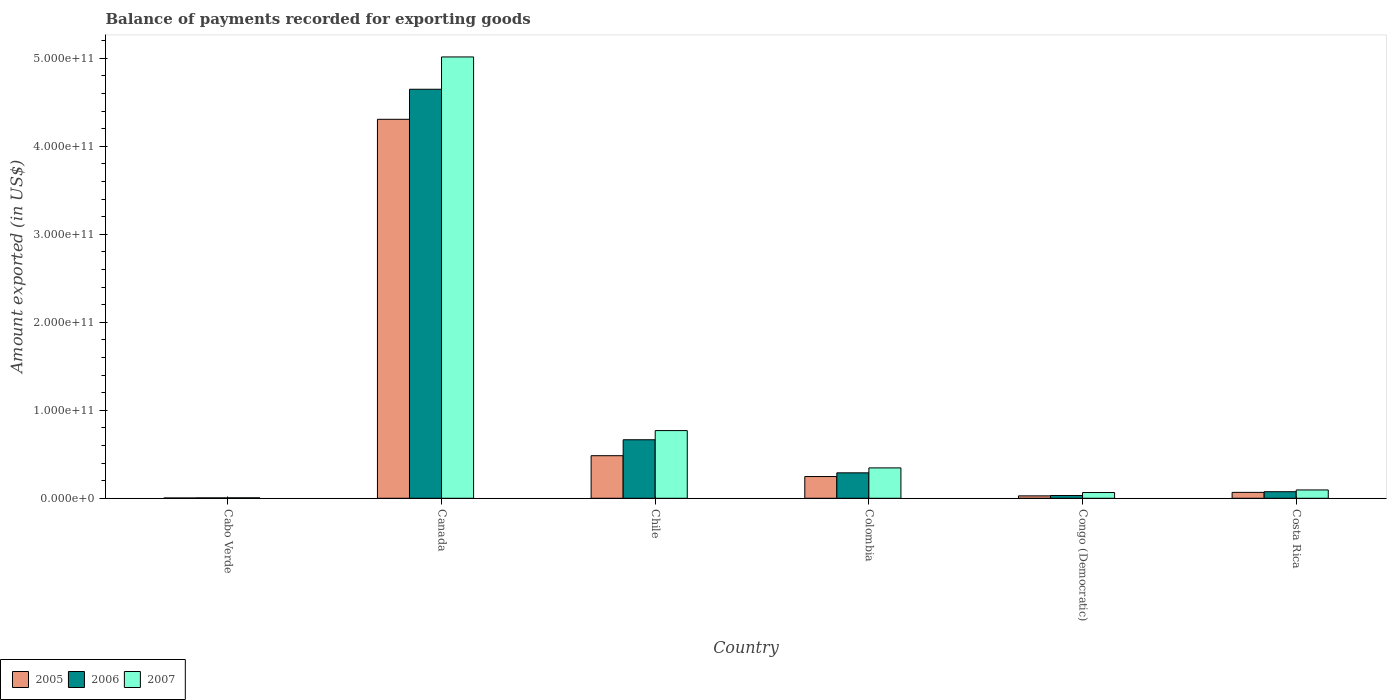How many different coloured bars are there?
Provide a succinct answer. 3. Are the number of bars on each tick of the X-axis equal?
Provide a succinct answer. Yes. How many bars are there on the 2nd tick from the left?
Provide a succinct answer. 3. How many bars are there on the 6th tick from the right?
Provide a succinct answer. 3. What is the label of the 5th group of bars from the left?
Keep it short and to the point. Congo (Democratic). In how many cases, is the number of bars for a given country not equal to the number of legend labels?
Your answer should be compact. 0. What is the amount exported in 2007 in Chile?
Make the answer very short. 7.69e+1. Across all countries, what is the maximum amount exported in 2006?
Make the answer very short. 4.65e+11. Across all countries, what is the minimum amount exported in 2007?
Your answer should be compact. 5.66e+08. In which country was the amount exported in 2007 minimum?
Your answer should be compact. Cabo Verde. What is the total amount exported in 2005 in the graph?
Offer a very short reply. 5.14e+11. What is the difference between the amount exported in 2006 in Chile and that in Colombia?
Ensure brevity in your answer.  3.76e+1. What is the difference between the amount exported in 2005 in Congo (Democratic) and the amount exported in 2006 in Canada?
Offer a terse response. -4.62e+11. What is the average amount exported in 2006 per country?
Ensure brevity in your answer.  9.52e+1. What is the difference between the amount exported of/in 2007 and amount exported of/in 2006 in Canada?
Provide a succinct answer. 3.67e+1. In how many countries, is the amount exported in 2005 greater than 380000000000 US$?
Your answer should be compact. 1. What is the ratio of the amount exported in 2007 in Colombia to that in Congo (Democratic)?
Offer a terse response. 5.28. Is the amount exported in 2006 in Canada less than that in Congo (Democratic)?
Keep it short and to the point. No. What is the difference between the highest and the second highest amount exported in 2006?
Give a very brief answer. 4.36e+11. What is the difference between the highest and the lowest amount exported in 2005?
Keep it short and to the point. 4.30e+11. In how many countries, is the amount exported in 2007 greater than the average amount exported in 2007 taken over all countries?
Offer a very short reply. 1. Is the sum of the amount exported in 2007 in Canada and Costa Rica greater than the maximum amount exported in 2005 across all countries?
Your answer should be very brief. Yes. What does the 3rd bar from the left in Colombia represents?
Your answer should be compact. 2007. Is it the case that in every country, the sum of the amount exported in 2006 and amount exported in 2005 is greater than the amount exported in 2007?
Give a very brief answer. No. Are all the bars in the graph horizontal?
Make the answer very short. No. How many countries are there in the graph?
Provide a short and direct response. 6. What is the difference between two consecutive major ticks on the Y-axis?
Give a very brief answer. 1.00e+11. Are the values on the major ticks of Y-axis written in scientific E-notation?
Your response must be concise. Yes. Does the graph contain any zero values?
Your answer should be very brief. No. Does the graph contain grids?
Your answer should be compact. No. How are the legend labels stacked?
Ensure brevity in your answer.  Horizontal. What is the title of the graph?
Give a very brief answer. Balance of payments recorded for exporting goods. Does "1994" appear as one of the legend labels in the graph?
Offer a terse response. No. What is the label or title of the X-axis?
Offer a terse response. Country. What is the label or title of the Y-axis?
Provide a short and direct response. Amount exported (in US$). What is the Amount exported (in US$) of 2005 in Cabo Verde?
Provide a succinct answer. 3.54e+08. What is the Amount exported (in US$) in 2006 in Cabo Verde?
Provide a succinct answer. 4.72e+08. What is the Amount exported (in US$) in 2007 in Cabo Verde?
Offer a terse response. 5.66e+08. What is the Amount exported (in US$) in 2005 in Canada?
Provide a succinct answer. 4.31e+11. What is the Amount exported (in US$) in 2006 in Canada?
Your answer should be compact. 4.65e+11. What is the Amount exported (in US$) in 2007 in Canada?
Offer a very short reply. 5.02e+11. What is the Amount exported (in US$) of 2005 in Chile?
Offer a terse response. 4.84e+1. What is the Amount exported (in US$) in 2006 in Chile?
Keep it short and to the point. 6.65e+1. What is the Amount exported (in US$) in 2007 in Chile?
Give a very brief answer. 7.69e+1. What is the Amount exported (in US$) of 2005 in Colombia?
Your answer should be compact. 2.47e+1. What is the Amount exported (in US$) in 2006 in Colombia?
Keep it short and to the point. 2.89e+1. What is the Amount exported (in US$) in 2007 in Colombia?
Offer a very short reply. 3.45e+1. What is the Amount exported (in US$) in 2005 in Congo (Democratic)?
Provide a succinct answer. 2.75e+09. What is the Amount exported (in US$) in 2006 in Congo (Democratic)?
Give a very brief answer. 3.14e+09. What is the Amount exported (in US$) in 2007 in Congo (Democratic)?
Make the answer very short. 6.54e+09. What is the Amount exported (in US$) of 2005 in Costa Rica?
Provide a short and direct response. 6.73e+09. What is the Amount exported (in US$) of 2006 in Costa Rica?
Ensure brevity in your answer.  7.47e+09. What is the Amount exported (in US$) in 2007 in Costa Rica?
Provide a succinct answer. 9.48e+09. Across all countries, what is the maximum Amount exported (in US$) in 2005?
Give a very brief answer. 4.31e+11. Across all countries, what is the maximum Amount exported (in US$) in 2006?
Make the answer very short. 4.65e+11. Across all countries, what is the maximum Amount exported (in US$) of 2007?
Give a very brief answer. 5.02e+11. Across all countries, what is the minimum Amount exported (in US$) of 2005?
Offer a terse response. 3.54e+08. Across all countries, what is the minimum Amount exported (in US$) of 2006?
Your answer should be very brief. 4.72e+08. Across all countries, what is the minimum Amount exported (in US$) in 2007?
Offer a very short reply. 5.66e+08. What is the total Amount exported (in US$) in 2005 in the graph?
Offer a very short reply. 5.14e+11. What is the total Amount exported (in US$) in 2006 in the graph?
Make the answer very short. 5.71e+11. What is the total Amount exported (in US$) of 2007 in the graph?
Give a very brief answer. 6.30e+11. What is the difference between the Amount exported (in US$) of 2005 in Cabo Verde and that in Canada?
Offer a terse response. -4.30e+11. What is the difference between the Amount exported (in US$) of 2006 in Cabo Verde and that in Canada?
Provide a succinct answer. -4.64e+11. What is the difference between the Amount exported (in US$) in 2007 in Cabo Verde and that in Canada?
Keep it short and to the point. -5.01e+11. What is the difference between the Amount exported (in US$) of 2005 in Cabo Verde and that in Chile?
Your answer should be compact. -4.80e+1. What is the difference between the Amount exported (in US$) in 2006 in Cabo Verde and that in Chile?
Provide a succinct answer. -6.60e+1. What is the difference between the Amount exported (in US$) of 2007 in Cabo Verde and that in Chile?
Offer a very short reply. -7.64e+1. What is the difference between the Amount exported (in US$) in 2005 in Cabo Verde and that in Colombia?
Your answer should be compact. -2.43e+1. What is the difference between the Amount exported (in US$) in 2006 in Cabo Verde and that in Colombia?
Offer a very short reply. -2.84e+1. What is the difference between the Amount exported (in US$) of 2007 in Cabo Verde and that in Colombia?
Make the answer very short. -3.40e+1. What is the difference between the Amount exported (in US$) of 2005 in Cabo Verde and that in Congo (Democratic)?
Your answer should be compact. -2.39e+09. What is the difference between the Amount exported (in US$) in 2006 in Cabo Verde and that in Congo (Democratic)?
Provide a succinct answer. -2.67e+09. What is the difference between the Amount exported (in US$) of 2007 in Cabo Verde and that in Congo (Democratic)?
Offer a terse response. -5.97e+09. What is the difference between the Amount exported (in US$) in 2005 in Cabo Verde and that in Costa Rica?
Provide a short and direct response. -6.37e+09. What is the difference between the Amount exported (in US$) in 2006 in Cabo Verde and that in Costa Rica?
Provide a succinct answer. -7.00e+09. What is the difference between the Amount exported (in US$) of 2007 in Cabo Verde and that in Costa Rica?
Keep it short and to the point. -8.91e+09. What is the difference between the Amount exported (in US$) of 2005 in Canada and that in Chile?
Provide a succinct answer. 3.82e+11. What is the difference between the Amount exported (in US$) in 2006 in Canada and that in Chile?
Provide a short and direct response. 3.98e+11. What is the difference between the Amount exported (in US$) of 2007 in Canada and that in Chile?
Ensure brevity in your answer.  4.25e+11. What is the difference between the Amount exported (in US$) of 2005 in Canada and that in Colombia?
Offer a terse response. 4.06e+11. What is the difference between the Amount exported (in US$) of 2006 in Canada and that in Colombia?
Offer a terse response. 4.36e+11. What is the difference between the Amount exported (in US$) in 2007 in Canada and that in Colombia?
Keep it short and to the point. 4.67e+11. What is the difference between the Amount exported (in US$) of 2005 in Canada and that in Congo (Democratic)?
Your response must be concise. 4.28e+11. What is the difference between the Amount exported (in US$) of 2006 in Canada and that in Congo (Democratic)?
Keep it short and to the point. 4.62e+11. What is the difference between the Amount exported (in US$) in 2007 in Canada and that in Congo (Democratic)?
Offer a terse response. 4.95e+11. What is the difference between the Amount exported (in US$) of 2005 in Canada and that in Costa Rica?
Offer a terse response. 4.24e+11. What is the difference between the Amount exported (in US$) in 2006 in Canada and that in Costa Rica?
Your response must be concise. 4.57e+11. What is the difference between the Amount exported (in US$) of 2007 in Canada and that in Costa Rica?
Provide a succinct answer. 4.92e+11. What is the difference between the Amount exported (in US$) of 2005 in Chile and that in Colombia?
Provide a short and direct response. 2.37e+1. What is the difference between the Amount exported (in US$) in 2006 in Chile and that in Colombia?
Keep it short and to the point. 3.76e+1. What is the difference between the Amount exported (in US$) of 2007 in Chile and that in Colombia?
Provide a short and direct response. 4.24e+1. What is the difference between the Amount exported (in US$) of 2005 in Chile and that in Congo (Democratic)?
Offer a very short reply. 4.57e+1. What is the difference between the Amount exported (in US$) in 2006 in Chile and that in Congo (Democratic)?
Your response must be concise. 6.34e+1. What is the difference between the Amount exported (in US$) in 2007 in Chile and that in Congo (Democratic)?
Give a very brief answer. 7.04e+1. What is the difference between the Amount exported (in US$) of 2005 in Chile and that in Costa Rica?
Provide a short and direct response. 4.17e+1. What is the difference between the Amount exported (in US$) of 2006 in Chile and that in Costa Rica?
Provide a short and direct response. 5.90e+1. What is the difference between the Amount exported (in US$) of 2007 in Chile and that in Costa Rica?
Keep it short and to the point. 6.75e+1. What is the difference between the Amount exported (in US$) of 2005 in Colombia and that in Congo (Democratic)?
Provide a succinct answer. 2.20e+1. What is the difference between the Amount exported (in US$) in 2006 in Colombia and that in Congo (Democratic)?
Make the answer very short. 2.58e+1. What is the difference between the Amount exported (in US$) in 2007 in Colombia and that in Congo (Democratic)?
Your answer should be very brief. 2.80e+1. What is the difference between the Amount exported (in US$) in 2005 in Colombia and that in Costa Rica?
Your response must be concise. 1.80e+1. What is the difference between the Amount exported (in US$) in 2006 in Colombia and that in Costa Rica?
Your answer should be very brief. 2.14e+1. What is the difference between the Amount exported (in US$) in 2007 in Colombia and that in Costa Rica?
Keep it short and to the point. 2.51e+1. What is the difference between the Amount exported (in US$) of 2005 in Congo (Democratic) and that in Costa Rica?
Provide a short and direct response. -3.98e+09. What is the difference between the Amount exported (in US$) in 2006 in Congo (Democratic) and that in Costa Rica?
Give a very brief answer. -4.33e+09. What is the difference between the Amount exported (in US$) of 2007 in Congo (Democratic) and that in Costa Rica?
Your answer should be compact. -2.94e+09. What is the difference between the Amount exported (in US$) in 2005 in Cabo Verde and the Amount exported (in US$) in 2006 in Canada?
Make the answer very short. -4.65e+11. What is the difference between the Amount exported (in US$) of 2005 in Cabo Verde and the Amount exported (in US$) of 2007 in Canada?
Your response must be concise. -5.01e+11. What is the difference between the Amount exported (in US$) of 2006 in Cabo Verde and the Amount exported (in US$) of 2007 in Canada?
Offer a very short reply. -5.01e+11. What is the difference between the Amount exported (in US$) of 2005 in Cabo Verde and the Amount exported (in US$) of 2006 in Chile?
Provide a short and direct response. -6.62e+1. What is the difference between the Amount exported (in US$) in 2005 in Cabo Verde and the Amount exported (in US$) in 2007 in Chile?
Make the answer very short. -7.66e+1. What is the difference between the Amount exported (in US$) in 2006 in Cabo Verde and the Amount exported (in US$) in 2007 in Chile?
Offer a very short reply. -7.65e+1. What is the difference between the Amount exported (in US$) of 2005 in Cabo Verde and the Amount exported (in US$) of 2006 in Colombia?
Make the answer very short. -2.86e+1. What is the difference between the Amount exported (in US$) in 2005 in Cabo Verde and the Amount exported (in US$) in 2007 in Colombia?
Provide a succinct answer. -3.42e+1. What is the difference between the Amount exported (in US$) in 2006 in Cabo Verde and the Amount exported (in US$) in 2007 in Colombia?
Ensure brevity in your answer.  -3.41e+1. What is the difference between the Amount exported (in US$) of 2005 in Cabo Verde and the Amount exported (in US$) of 2006 in Congo (Democratic)?
Ensure brevity in your answer.  -2.78e+09. What is the difference between the Amount exported (in US$) in 2005 in Cabo Verde and the Amount exported (in US$) in 2007 in Congo (Democratic)?
Make the answer very short. -6.19e+09. What is the difference between the Amount exported (in US$) in 2006 in Cabo Verde and the Amount exported (in US$) in 2007 in Congo (Democratic)?
Ensure brevity in your answer.  -6.07e+09. What is the difference between the Amount exported (in US$) in 2005 in Cabo Verde and the Amount exported (in US$) in 2006 in Costa Rica?
Ensure brevity in your answer.  -7.12e+09. What is the difference between the Amount exported (in US$) of 2005 in Cabo Verde and the Amount exported (in US$) of 2007 in Costa Rica?
Offer a very short reply. -9.12e+09. What is the difference between the Amount exported (in US$) of 2006 in Cabo Verde and the Amount exported (in US$) of 2007 in Costa Rica?
Make the answer very short. -9.00e+09. What is the difference between the Amount exported (in US$) in 2005 in Canada and the Amount exported (in US$) in 2006 in Chile?
Provide a short and direct response. 3.64e+11. What is the difference between the Amount exported (in US$) of 2005 in Canada and the Amount exported (in US$) of 2007 in Chile?
Keep it short and to the point. 3.54e+11. What is the difference between the Amount exported (in US$) of 2006 in Canada and the Amount exported (in US$) of 2007 in Chile?
Ensure brevity in your answer.  3.88e+11. What is the difference between the Amount exported (in US$) of 2005 in Canada and the Amount exported (in US$) of 2006 in Colombia?
Make the answer very short. 4.02e+11. What is the difference between the Amount exported (in US$) in 2005 in Canada and the Amount exported (in US$) in 2007 in Colombia?
Offer a terse response. 3.96e+11. What is the difference between the Amount exported (in US$) of 2006 in Canada and the Amount exported (in US$) of 2007 in Colombia?
Offer a terse response. 4.30e+11. What is the difference between the Amount exported (in US$) of 2005 in Canada and the Amount exported (in US$) of 2006 in Congo (Democratic)?
Your answer should be compact. 4.28e+11. What is the difference between the Amount exported (in US$) in 2005 in Canada and the Amount exported (in US$) in 2007 in Congo (Democratic)?
Offer a terse response. 4.24e+11. What is the difference between the Amount exported (in US$) of 2006 in Canada and the Amount exported (in US$) of 2007 in Congo (Democratic)?
Offer a terse response. 4.58e+11. What is the difference between the Amount exported (in US$) in 2005 in Canada and the Amount exported (in US$) in 2006 in Costa Rica?
Your answer should be very brief. 4.23e+11. What is the difference between the Amount exported (in US$) in 2005 in Canada and the Amount exported (in US$) in 2007 in Costa Rica?
Your answer should be compact. 4.21e+11. What is the difference between the Amount exported (in US$) in 2006 in Canada and the Amount exported (in US$) in 2007 in Costa Rica?
Ensure brevity in your answer.  4.55e+11. What is the difference between the Amount exported (in US$) in 2005 in Chile and the Amount exported (in US$) in 2006 in Colombia?
Provide a succinct answer. 1.95e+1. What is the difference between the Amount exported (in US$) of 2005 in Chile and the Amount exported (in US$) of 2007 in Colombia?
Your answer should be compact. 1.39e+1. What is the difference between the Amount exported (in US$) of 2006 in Chile and the Amount exported (in US$) of 2007 in Colombia?
Your answer should be very brief. 3.20e+1. What is the difference between the Amount exported (in US$) of 2005 in Chile and the Amount exported (in US$) of 2006 in Congo (Democratic)?
Offer a terse response. 4.53e+1. What is the difference between the Amount exported (in US$) in 2005 in Chile and the Amount exported (in US$) in 2007 in Congo (Democratic)?
Provide a succinct answer. 4.19e+1. What is the difference between the Amount exported (in US$) of 2006 in Chile and the Amount exported (in US$) of 2007 in Congo (Democratic)?
Offer a terse response. 6.00e+1. What is the difference between the Amount exported (in US$) in 2005 in Chile and the Amount exported (in US$) in 2006 in Costa Rica?
Provide a short and direct response. 4.09e+1. What is the difference between the Amount exported (in US$) of 2005 in Chile and the Amount exported (in US$) of 2007 in Costa Rica?
Offer a terse response. 3.89e+1. What is the difference between the Amount exported (in US$) of 2006 in Chile and the Amount exported (in US$) of 2007 in Costa Rica?
Your answer should be very brief. 5.70e+1. What is the difference between the Amount exported (in US$) of 2005 in Colombia and the Amount exported (in US$) of 2006 in Congo (Democratic)?
Give a very brief answer. 2.16e+1. What is the difference between the Amount exported (in US$) of 2005 in Colombia and the Amount exported (in US$) of 2007 in Congo (Democratic)?
Make the answer very short. 1.82e+1. What is the difference between the Amount exported (in US$) in 2006 in Colombia and the Amount exported (in US$) in 2007 in Congo (Democratic)?
Your response must be concise. 2.24e+1. What is the difference between the Amount exported (in US$) in 2005 in Colombia and the Amount exported (in US$) in 2006 in Costa Rica?
Your response must be concise. 1.72e+1. What is the difference between the Amount exported (in US$) in 2005 in Colombia and the Amount exported (in US$) in 2007 in Costa Rica?
Provide a short and direct response. 1.52e+1. What is the difference between the Amount exported (in US$) of 2006 in Colombia and the Amount exported (in US$) of 2007 in Costa Rica?
Keep it short and to the point. 1.94e+1. What is the difference between the Amount exported (in US$) in 2005 in Congo (Democratic) and the Amount exported (in US$) in 2006 in Costa Rica?
Keep it short and to the point. -4.72e+09. What is the difference between the Amount exported (in US$) of 2005 in Congo (Democratic) and the Amount exported (in US$) of 2007 in Costa Rica?
Offer a terse response. -6.73e+09. What is the difference between the Amount exported (in US$) in 2006 in Congo (Democratic) and the Amount exported (in US$) in 2007 in Costa Rica?
Offer a terse response. -6.34e+09. What is the average Amount exported (in US$) in 2005 per country?
Give a very brief answer. 8.56e+1. What is the average Amount exported (in US$) in 2006 per country?
Your answer should be compact. 9.52e+1. What is the average Amount exported (in US$) of 2007 per country?
Ensure brevity in your answer.  1.05e+11. What is the difference between the Amount exported (in US$) of 2005 and Amount exported (in US$) of 2006 in Cabo Verde?
Ensure brevity in your answer.  -1.19e+08. What is the difference between the Amount exported (in US$) of 2005 and Amount exported (in US$) of 2007 in Cabo Verde?
Make the answer very short. -2.12e+08. What is the difference between the Amount exported (in US$) of 2006 and Amount exported (in US$) of 2007 in Cabo Verde?
Provide a succinct answer. -9.37e+07. What is the difference between the Amount exported (in US$) of 2005 and Amount exported (in US$) of 2006 in Canada?
Provide a short and direct response. -3.41e+1. What is the difference between the Amount exported (in US$) in 2005 and Amount exported (in US$) in 2007 in Canada?
Keep it short and to the point. -7.09e+1. What is the difference between the Amount exported (in US$) in 2006 and Amount exported (in US$) in 2007 in Canada?
Your answer should be compact. -3.67e+1. What is the difference between the Amount exported (in US$) of 2005 and Amount exported (in US$) of 2006 in Chile?
Your response must be concise. -1.81e+1. What is the difference between the Amount exported (in US$) of 2005 and Amount exported (in US$) of 2007 in Chile?
Your answer should be very brief. -2.85e+1. What is the difference between the Amount exported (in US$) of 2006 and Amount exported (in US$) of 2007 in Chile?
Keep it short and to the point. -1.04e+1. What is the difference between the Amount exported (in US$) in 2005 and Amount exported (in US$) in 2006 in Colombia?
Offer a terse response. -4.21e+09. What is the difference between the Amount exported (in US$) in 2005 and Amount exported (in US$) in 2007 in Colombia?
Your answer should be compact. -9.83e+09. What is the difference between the Amount exported (in US$) in 2006 and Amount exported (in US$) in 2007 in Colombia?
Ensure brevity in your answer.  -5.61e+09. What is the difference between the Amount exported (in US$) of 2005 and Amount exported (in US$) of 2006 in Congo (Democratic)?
Your answer should be compact. -3.92e+08. What is the difference between the Amount exported (in US$) in 2005 and Amount exported (in US$) in 2007 in Congo (Democratic)?
Keep it short and to the point. -3.79e+09. What is the difference between the Amount exported (in US$) in 2006 and Amount exported (in US$) in 2007 in Congo (Democratic)?
Offer a very short reply. -3.40e+09. What is the difference between the Amount exported (in US$) of 2005 and Amount exported (in US$) of 2006 in Costa Rica?
Your answer should be compact. -7.41e+08. What is the difference between the Amount exported (in US$) of 2005 and Amount exported (in US$) of 2007 in Costa Rica?
Provide a succinct answer. -2.75e+09. What is the difference between the Amount exported (in US$) in 2006 and Amount exported (in US$) in 2007 in Costa Rica?
Provide a short and direct response. -2.01e+09. What is the ratio of the Amount exported (in US$) in 2005 in Cabo Verde to that in Canada?
Your answer should be compact. 0. What is the ratio of the Amount exported (in US$) in 2006 in Cabo Verde to that in Canada?
Offer a terse response. 0. What is the ratio of the Amount exported (in US$) of 2007 in Cabo Verde to that in Canada?
Provide a short and direct response. 0. What is the ratio of the Amount exported (in US$) of 2005 in Cabo Verde to that in Chile?
Keep it short and to the point. 0.01. What is the ratio of the Amount exported (in US$) of 2006 in Cabo Verde to that in Chile?
Ensure brevity in your answer.  0.01. What is the ratio of the Amount exported (in US$) of 2007 in Cabo Verde to that in Chile?
Ensure brevity in your answer.  0.01. What is the ratio of the Amount exported (in US$) of 2005 in Cabo Verde to that in Colombia?
Ensure brevity in your answer.  0.01. What is the ratio of the Amount exported (in US$) of 2006 in Cabo Verde to that in Colombia?
Provide a short and direct response. 0.02. What is the ratio of the Amount exported (in US$) of 2007 in Cabo Verde to that in Colombia?
Provide a short and direct response. 0.02. What is the ratio of the Amount exported (in US$) in 2005 in Cabo Verde to that in Congo (Democratic)?
Make the answer very short. 0.13. What is the ratio of the Amount exported (in US$) of 2006 in Cabo Verde to that in Congo (Democratic)?
Ensure brevity in your answer.  0.15. What is the ratio of the Amount exported (in US$) of 2007 in Cabo Verde to that in Congo (Democratic)?
Provide a short and direct response. 0.09. What is the ratio of the Amount exported (in US$) of 2005 in Cabo Verde to that in Costa Rica?
Ensure brevity in your answer.  0.05. What is the ratio of the Amount exported (in US$) of 2006 in Cabo Verde to that in Costa Rica?
Offer a very short reply. 0.06. What is the ratio of the Amount exported (in US$) in 2007 in Cabo Verde to that in Costa Rica?
Ensure brevity in your answer.  0.06. What is the ratio of the Amount exported (in US$) of 2005 in Canada to that in Chile?
Offer a very short reply. 8.9. What is the ratio of the Amount exported (in US$) in 2006 in Canada to that in Chile?
Provide a short and direct response. 6.99. What is the ratio of the Amount exported (in US$) of 2007 in Canada to that in Chile?
Your answer should be very brief. 6.52. What is the ratio of the Amount exported (in US$) of 2005 in Canada to that in Colombia?
Offer a very short reply. 17.44. What is the ratio of the Amount exported (in US$) of 2006 in Canada to that in Colombia?
Your response must be concise. 16.08. What is the ratio of the Amount exported (in US$) in 2007 in Canada to that in Colombia?
Keep it short and to the point. 14.53. What is the ratio of the Amount exported (in US$) in 2005 in Canada to that in Congo (Democratic)?
Provide a short and direct response. 156.86. What is the ratio of the Amount exported (in US$) of 2006 in Canada to that in Congo (Democratic)?
Provide a succinct answer. 148.16. What is the ratio of the Amount exported (in US$) in 2007 in Canada to that in Congo (Democratic)?
Offer a very short reply. 76.7. What is the ratio of the Amount exported (in US$) in 2005 in Canada to that in Costa Rica?
Offer a terse response. 64.02. What is the ratio of the Amount exported (in US$) of 2006 in Canada to that in Costa Rica?
Ensure brevity in your answer.  62.24. What is the ratio of the Amount exported (in US$) of 2007 in Canada to that in Costa Rica?
Offer a terse response. 52.93. What is the ratio of the Amount exported (in US$) of 2005 in Chile to that in Colombia?
Your answer should be very brief. 1.96. What is the ratio of the Amount exported (in US$) in 2006 in Chile to that in Colombia?
Your response must be concise. 2.3. What is the ratio of the Amount exported (in US$) of 2007 in Chile to that in Colombia?
Your answer should be very brief. 2.23. What is the ratio of the Amount exported (in US$) in 2005 in Chile to that in Congo (Democratic)?
Ensure brevity in your answer.  17.63. What is the ratio of the Amount exported (in US$) of 2006 in Chile to that in Congo (Democratic)?
Give a very brief answer. 21.2. What is the ratio of the Amount exported (in US$) of 2007 in Chile to that in Congo (Democratic)?
Provide a short and direct response. 11.76. What is the ratio of the Amount exported (in US$) in 2005 in Chile to that in Costa Rica?
Provide a succinct answer. 7.19. What is the ratio of the Amount exported (in US$) of 2006 in Chile to that in Costa Rica?
Give a very brief answer. 8.9. What is the ratio of the Amount exported (in US$) of 2007 in Chile to that in Costa Rica?
Your answer should be very brief. 8.12. What is the ratio of the Amount exported (in US$) of 2005 in Colombia to that in Congo (Democratic)?
Keep it short and to the point. 9. What is the ratio of the Amount exported (in US$) in 2006 in Colombia to that in Congo (Democratic)?
Your response must be concise. 9.22. What is the ratio of the Amount exported (in US$) of 2007 in Colombia to that in Congo (Democratic)?
Ensure brevity in your answer.  5.28. What is the ratio of the Amount exported (in US$) of 2005 in Colombia to that in Costa Rica?
Keep it short and to the point. 3.67. What is the ratio of the Amount exported (in US$) of 2006 in Colombia to that in Costa Rica?
Your answer should be very brief. 3.87. What is the ratio of the Amount exported (in US$) in 2007 in Colombia to that in Costa Rica?
Provide a succinct answer. 3.64. What is the ratio of the Amount exported (in US$) of 2005 in Congo (Democratic) to that in Costa Rica?
Provide a succinct answer. 0.41. What is the ratio of the Amount exported (in US$) in 2006 in Congo (Democratic) to that in Costa Rica?
Your answer should be compact. 0.42. What is the ratio of the Amount exported (in US$) of 2007 in Congo (Democratic) to that in Costa Rica?
Give a very brief answer. 0.69. What is the difference between the highest and the second highest Amount exported (in US$) in 2005?
Provide a succinct answer. 3.82e+11. What is the difference between the highest and the second highest Amount exported (in US$) of 2006?
Provide a short and direct response. 3.98e+11. What is the difference between the highest and the second highest Amount exported (in US$) in 2007?
Provide a short and direct response. 4.25e+11. What is the difference between the highest and the lowest Amount exported (in US$) of 2005?
Give a very brief answer. 4.30e+11. What is the difference between the highest and the lowest Amount exported (in US$) of 2006?
Offer a terse response. 4.64e+11. What is the difference between the highest and the lowest Amount exported (in US$) of 2007?
Ensure brevity in your answer.  5.01e+11. 